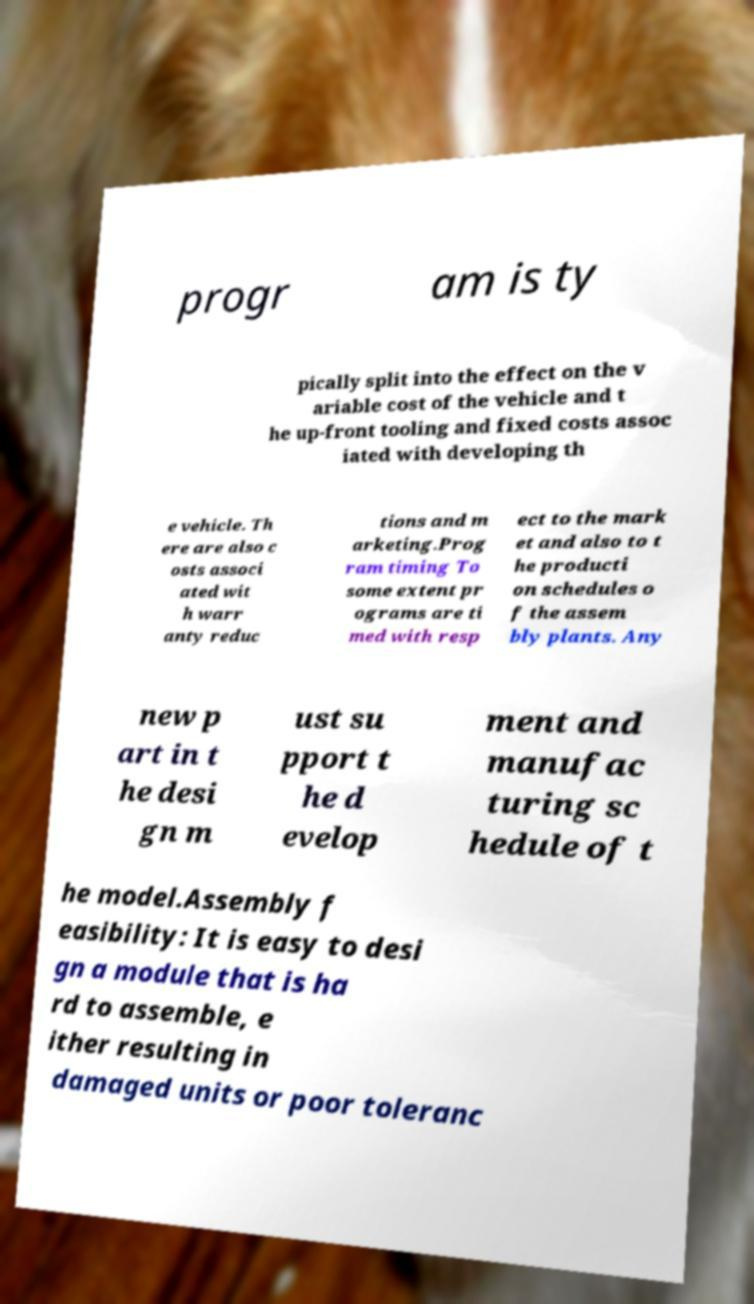Please identify and transcribe the text found in this image. progr am is ty pically split into the effect on the v ariable cost of the vehicle and t he up-front tooling and fixed costs assoc iated with developing th e vehicle. Th ere are also c osts associ ated wit h warr anty reduc tions and m arketing.Prog ram timing To some extent pr ograms are ti med with resp ect to the mark et and also to t he producti on schedules o f the assem bly plants. Any new p art in t he desi gn m ust su pport t he d evelop ment and manufac turing sc hedule of t he model.Assembly f easibility: It is easy to desi gn a module that is ha rd to assemble, e ither resulting in damaged units or poor toleranc 